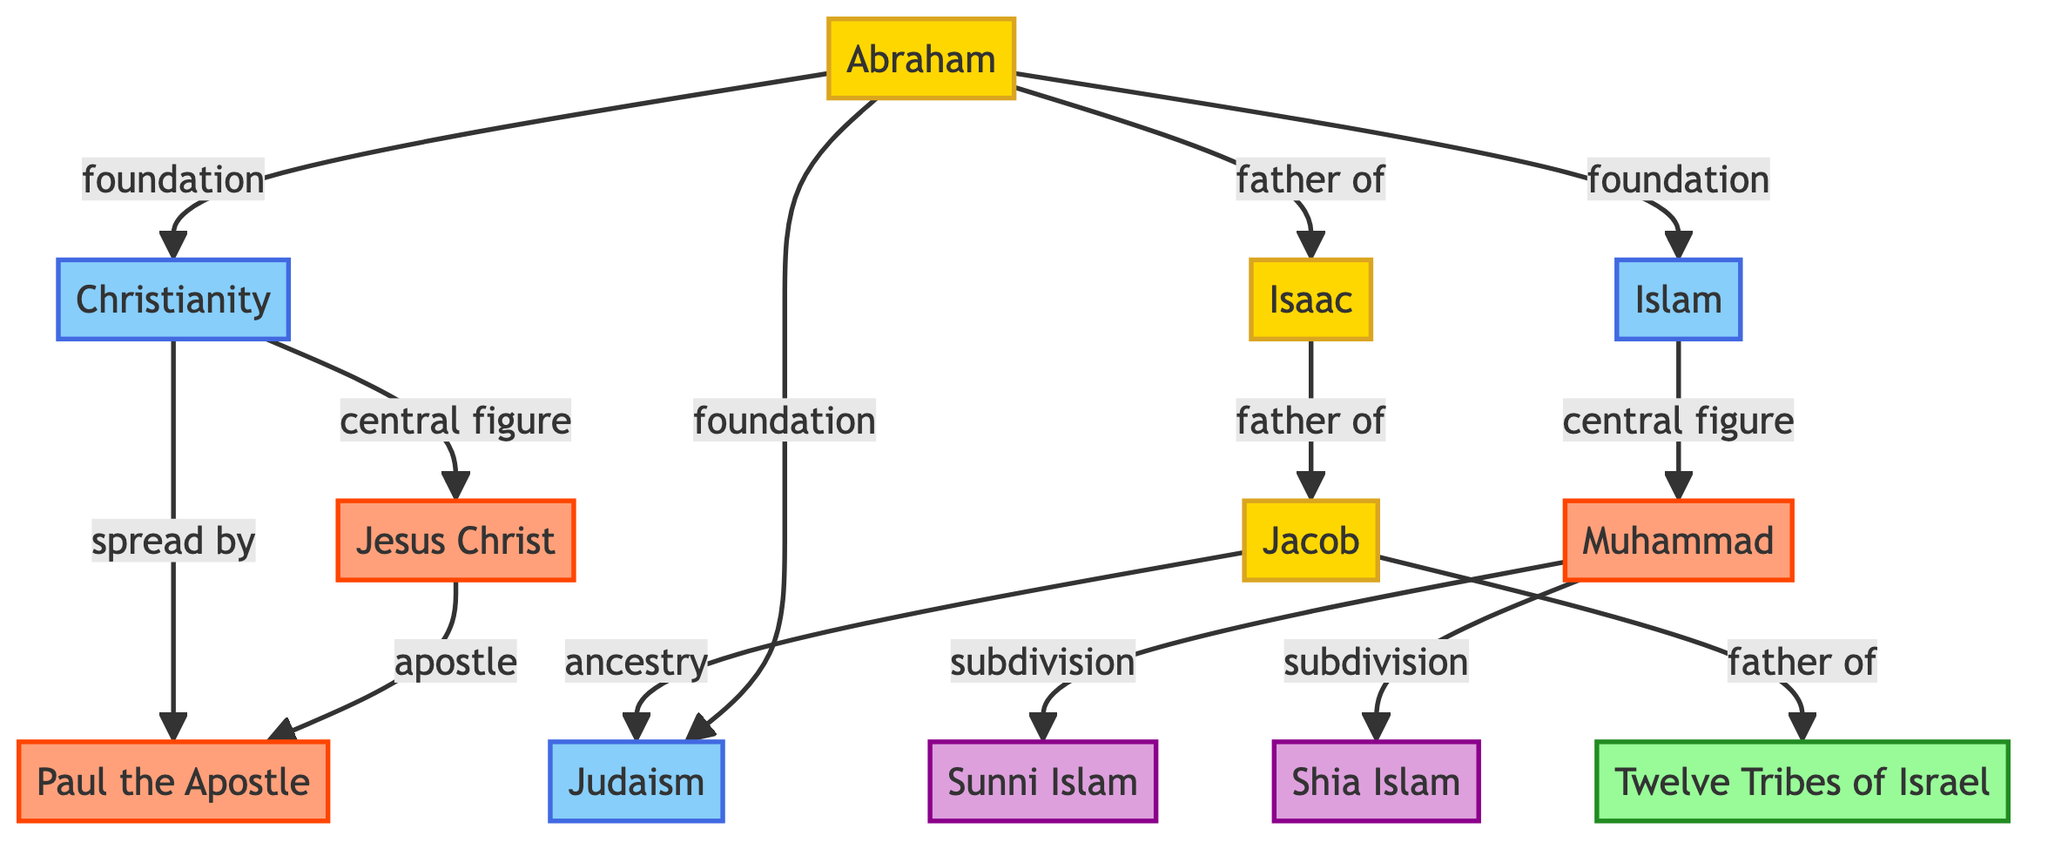What is the total number of nodes in the diagram? By counting the distinct entities presented, there are 12 nodes including patriarchs, religions, figures, tribes, and denominations.
Answer: 12 Who is the father of Jacob? The diagram indicates that Isaac (N5) is the father of Jacob (N6) through a directed edge labeled 'father_of'.
Answer: Isaac What religion is directly linked to Abraham as its foundation? The diagram shows three edges from Abraham (N1) to Judaism (N2), Christianity (N3), and Islam (N4) labeled 'foundation'.
Answer: Judaism, Christianity, Islam What are the two subdivisions of Islam according to the diagram? The edges from Muhammad (N10) lead to Sunni Islam (N11) and Shia Islam (N12) as subdivisions, according to the labels 'subdivision'.
Answer: Sunni Islam, Shia Islam Who is considered the central figure in Christianity? The diagram indicates that Jesus Christ (N8) is the central figure in Christianity as shown by the edge connecting Christianity (N3) to Jesus Christ (N8) labeled 'central_figure'.
Answer: Jesus Christ What relationship does Jacob have with the Twelve Tribes of Israel? The direct edge from Jacob (N6) to the Twelve Tribes of Israel (N7) labeled 'father_of' denotes that Jacob is the father of the Twelve Tribes of Israel.
Answer: father Which figure is identified as an apostle in the diagram? The diagram shows a connection from Jesus Christ (N8) to Paul the Apostle (N9) labeled 'apostle', indicating Paul's role.
Answer: Paul the Apostle How many types of denominations are shown under Islam? The relationships leading from Muhammad (N10) to the two denominations (N11: Sunni Islam and N12: Shia Islam) imply there are two denominations depicted.
Answer: 2 What is the connection between Jacob and Judaism? The diagram shows that Jacob (N6) has an ancestry relationship with Judaism (N2) through directed edges. Specifically, Jacob is part of the lineage that leads to Judaism.
Answer: ancestry 